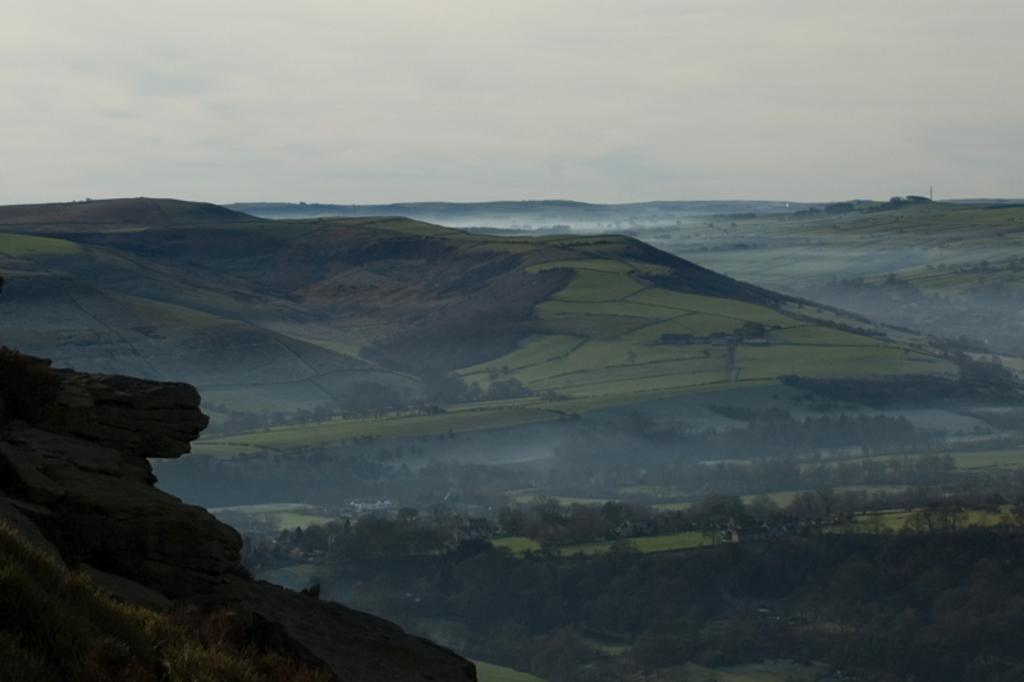What type of vegetation is present in the image? There are trees in the image. What is the color of the trees? The trees are green. What other type of vegetation is present in the image? There is grass in the image. What is the color of the grass? The grass is green. What can be seen in the background of the image? Water is visible in the background. What is the color of the sky in the image? The sky is white in color. Can you see any eggs in the image? There are no eggs present in the image. Are there any fairies flying around the trees in the image? There are no fairies present in the image. 